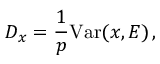<formula> <loc_0><loc_0><loc_500><loc_500>D _ { x } = \frac { 1 } { p } V a r ( x , E ) \, ,</formula> 